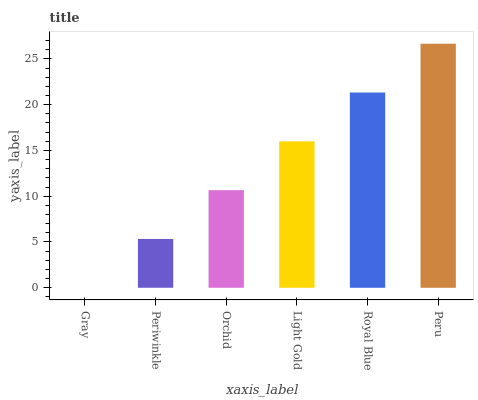Is Periwinkle the minimum?
Answer yes or no. No. Is Periwinkle the maximum?
Answer yes or no. No. Is Periwinkle greater than Gray?
Answer yes or no. Yes. Is Gray less than Periwinkle?
Answer yes or no. Yes. Is Gray greater than Periwinkle?
Answer yes or no. No. Is Periwinkle less than Gray?
Answer yes or no. No. Is Light Gold the high median?
Answer yes or no. Yes. Is Orchid the low median?
Answer yes or no. Yes. Is Gray the high median?
Answer yes or no. No. Is Light Gold the low median?
Answer yes or no. No. 